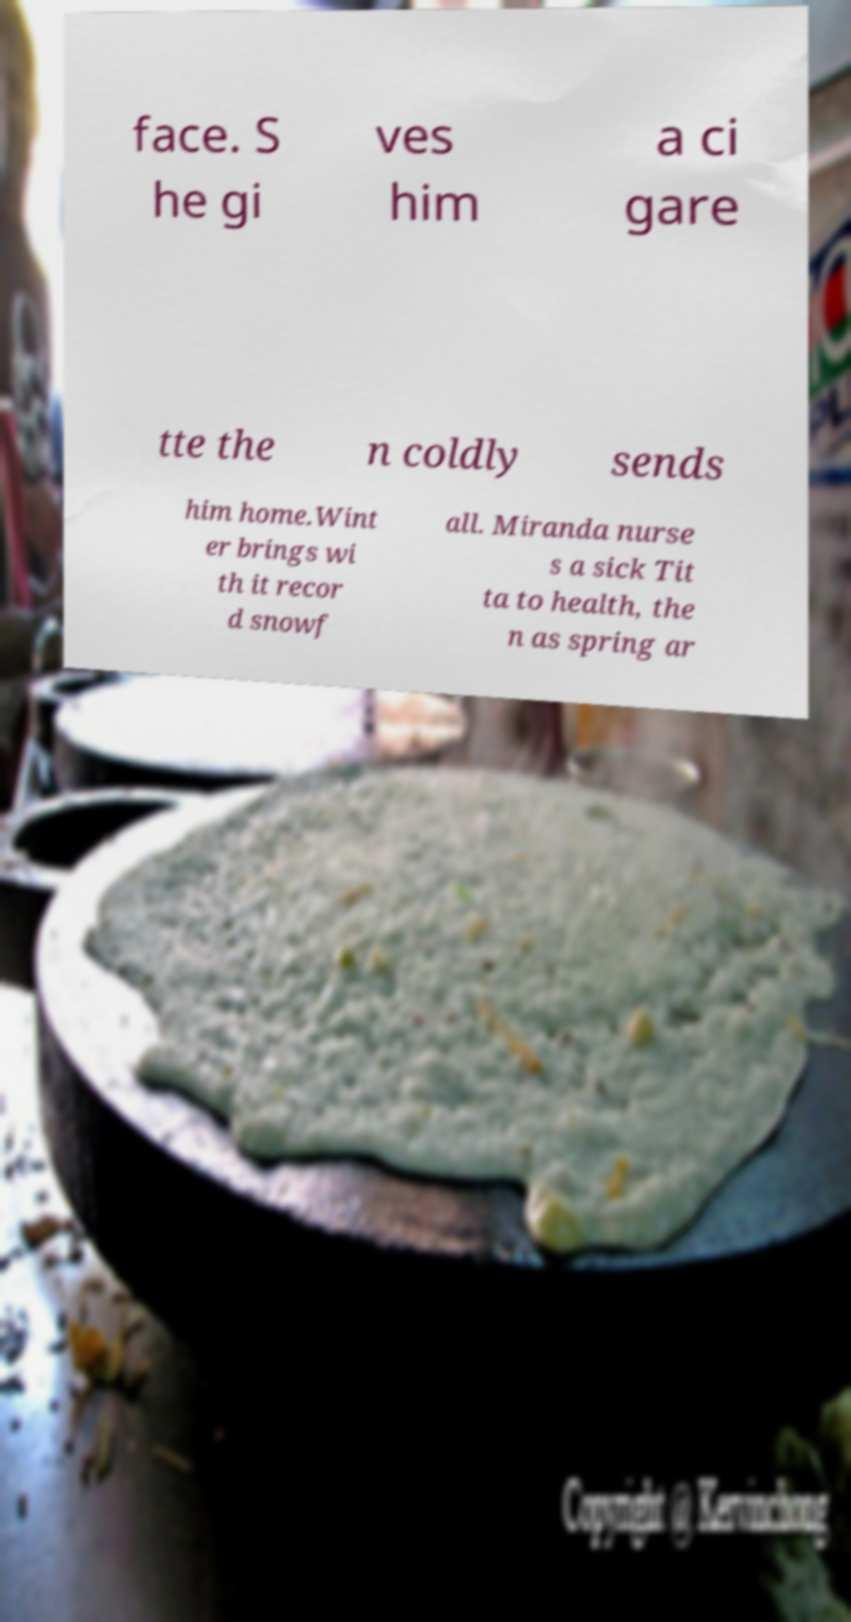Can you read and provide the text displayed in the image?This photo seems to have some interesting text. Can you extract and type it out for me? face. S he gi ves him a ci gare tte the n coldly sends him home.Wint er brings wi th it recor d snowf all. Miranda nurse s a sick Tit ta to health, the n as spring ar 